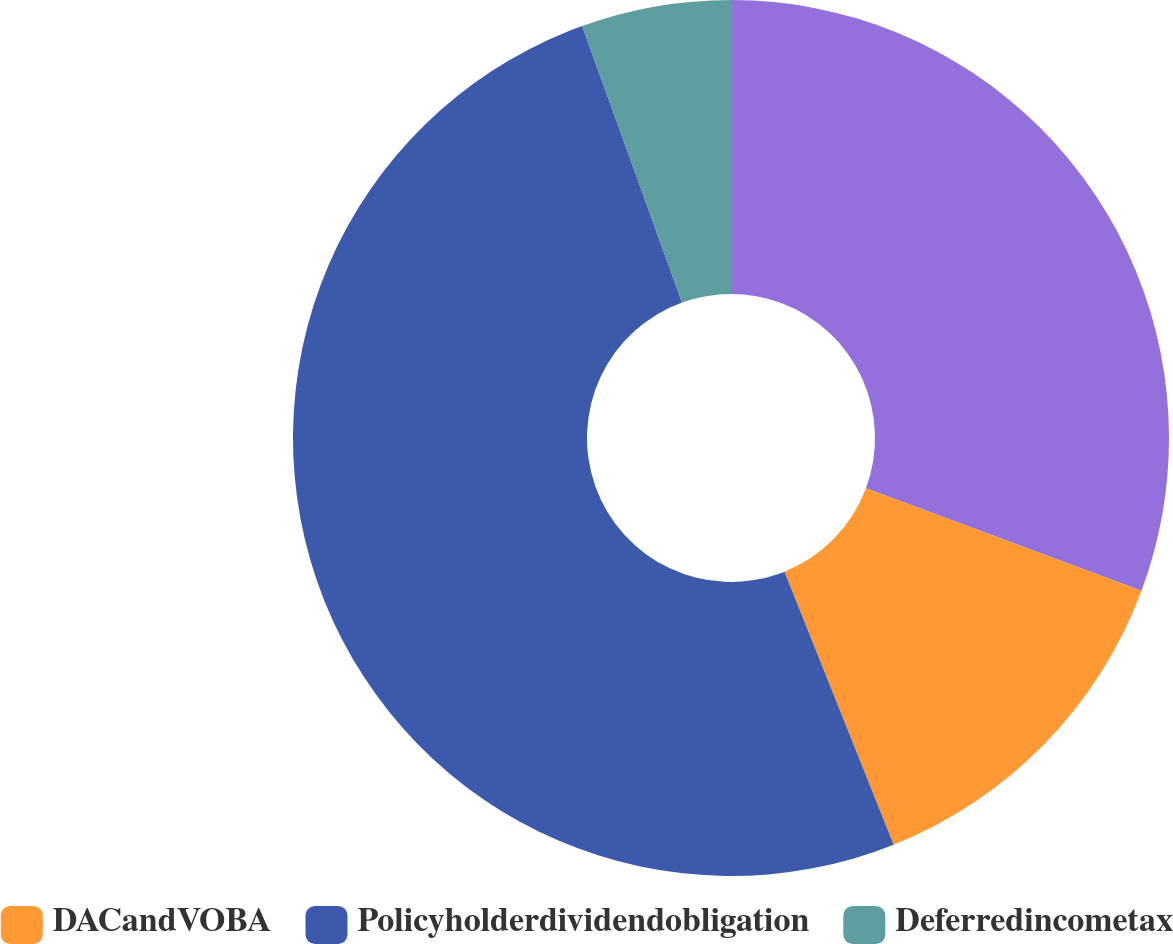<chart> <loc_0><loc_0><loc_500><loc_500><pie_chart><ecel><fcel>DACandVOBA<fcel>Policyholderdividendobligation<fcel>Deferredincometax<nl><fcel>30.67%<fcel>13.27%<fcel>50.53%<fcel>5.52%<nl></chart> 